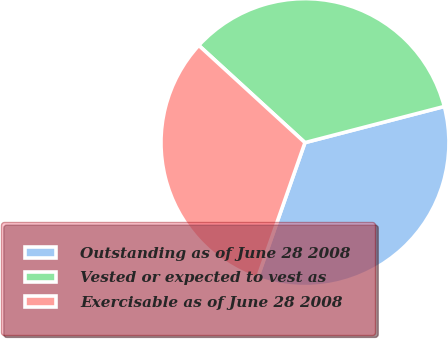<chart> <loc_0><loc_0><loc_500><loc_500><pie_chart><fcel>Outstanding as of June 28 2008<fcel>Vested or expected to vest as<fcel>Exercisable as of June 28 2008<nl><fcel>34.41%<fcel>34.16%<fcel>31.43%<nl></chart> 